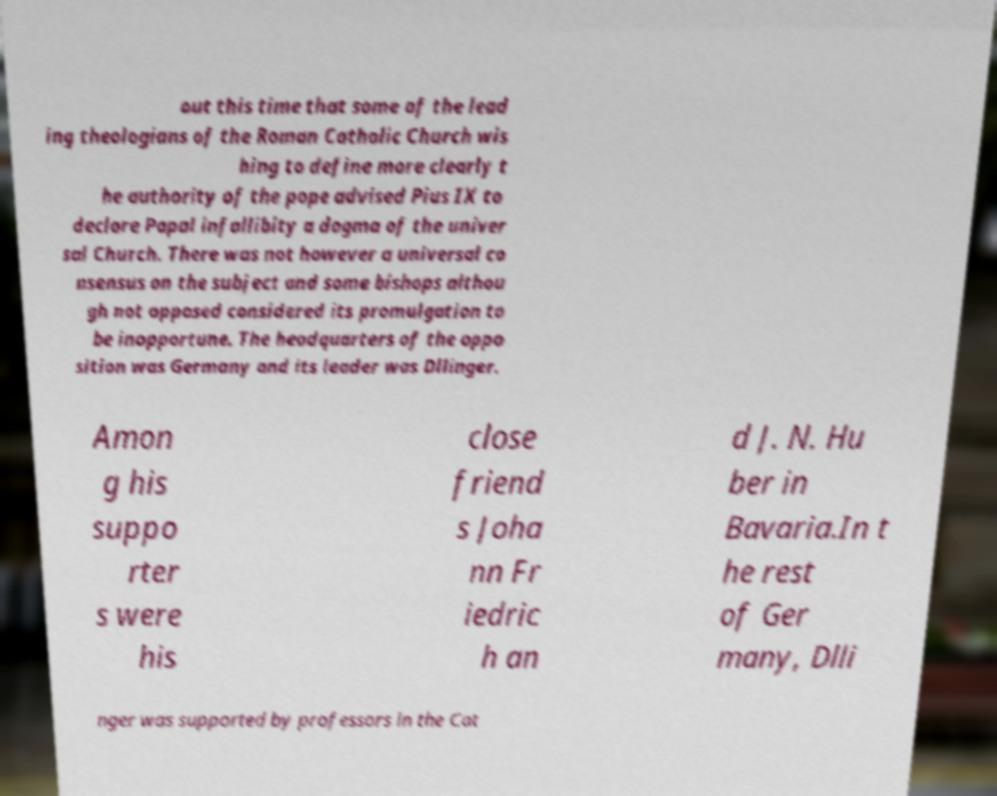Can you read and provide the text displayed in the image?This photo seems to have some interesting text. Can you extract and type it out for me? out this time that some of the lead ing theologians of the Roman Catholic Church wis hing to define more clearly t he authority of the pope advised Pius IX to declare Papal infallibity a dogma of the univer sal Church. There was not however a universal co nsensus on the subject and some bishops althou gh not opposed considered its promulgation to be inopportune. The headquarters of the oppo sition was Germany and its leader was Dllinger. Amon g his suppo rter s were his close friend s Joha nn Fr iedric h an d J. N. Hu ber in Bavaria.In t he rest of Ger many, Dlli nger was supported by professors in the Cat 